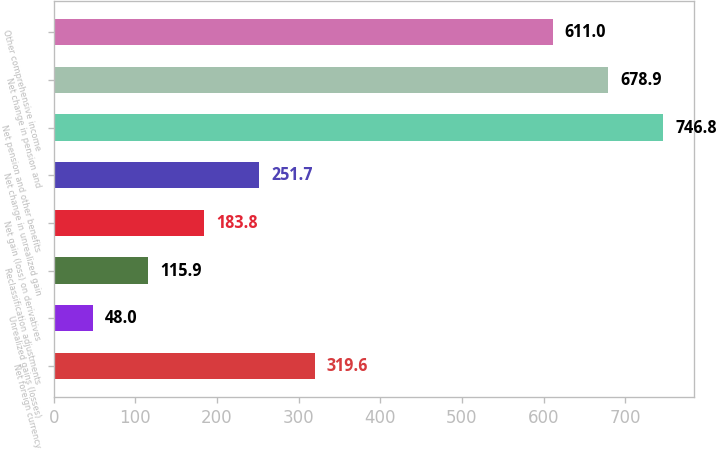<chart> <loc_0><loc_0><loc_500><loc_500><bar_chart><fcel>Net foreign currency<fcel>Unrealized gains (losses)<fcel>Reclassification adjustments<fcel>Net gain (loss) on derivatives<fcel>Net change in unrealized gain<fcel>Net pension and other benefits<fcel>Net change in pension and<fcel>Other comprehensive income<nl><fcel>319.6<fcel>48<fcel>115.9<fcel>183.8<fcel>251.7<fcel>746.8<fcel>678.9<fcel>611<nl></chart> 